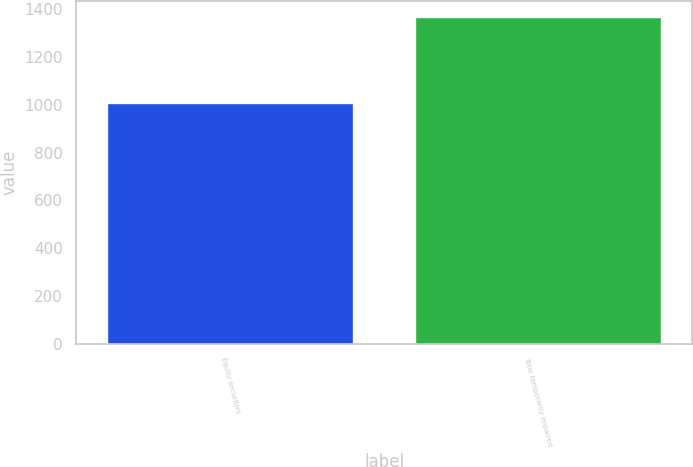<chart> <loc_0><loc_0><loc_500><loc_500><bar_chart><fcel>Equity securities<fcel>Total temporarily impaired<nl><fcel>1006<fcel>1368<nl></chart> 